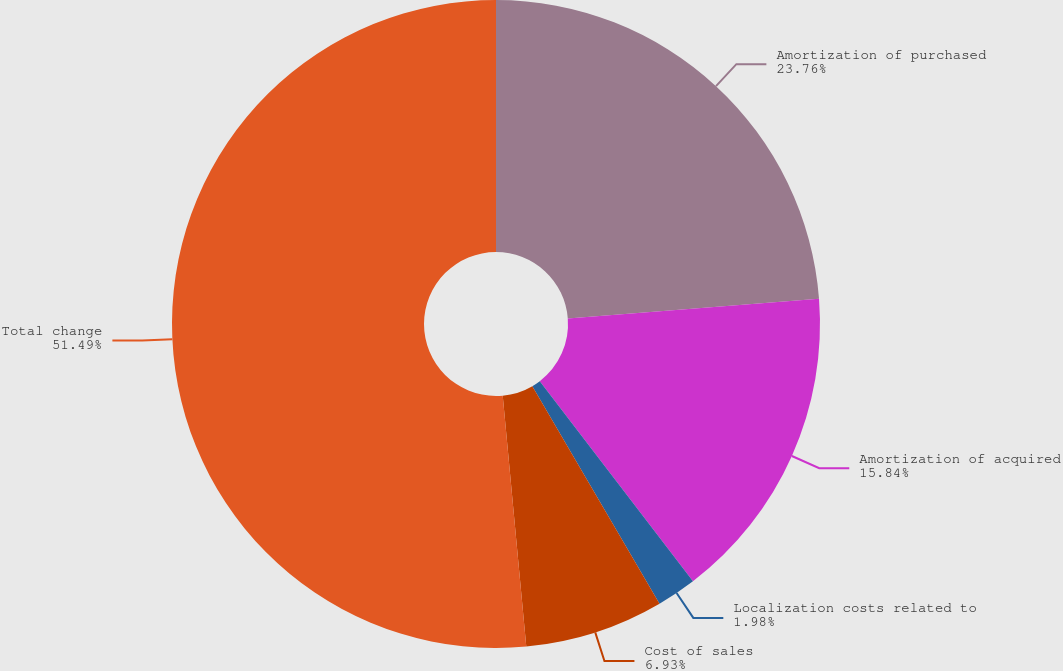Convert chart. <chart><loc_0><loc_0><loc_500><loc_500><pie_chart><fcel>Amortization of purchased<fcel>Amortization of acquired<fcel>Localization costs related to<fcel>Cost of sales<fcel>Total change<nl><fcel>23.76%<fcel>15.84%<fcel>1.98%<fcel>6.93%<fcel>51.49%<nl></chart> 